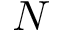Convert formula to latex. <formula><loc_0><loc_0><loc_500><loc_500>N</formula> 